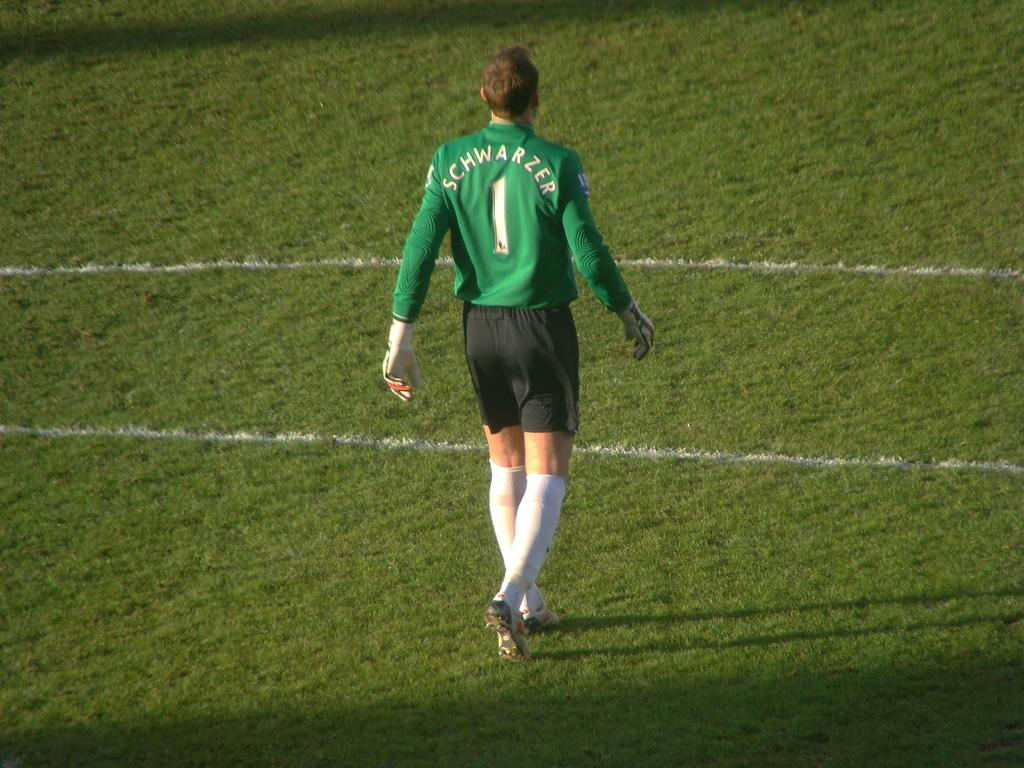What is the main subject in the center of the image? There is a person in the center of the image. What type of surface is visible at the bottom of the image? There is grass at the bottom of the image. What type of stem can be seen growing from the person's head in the image? There is no stem growing from the person's head in the image. Can you tell me the total cost of the items purchased based on the receipt in the image? There is no receipt present in the image. 